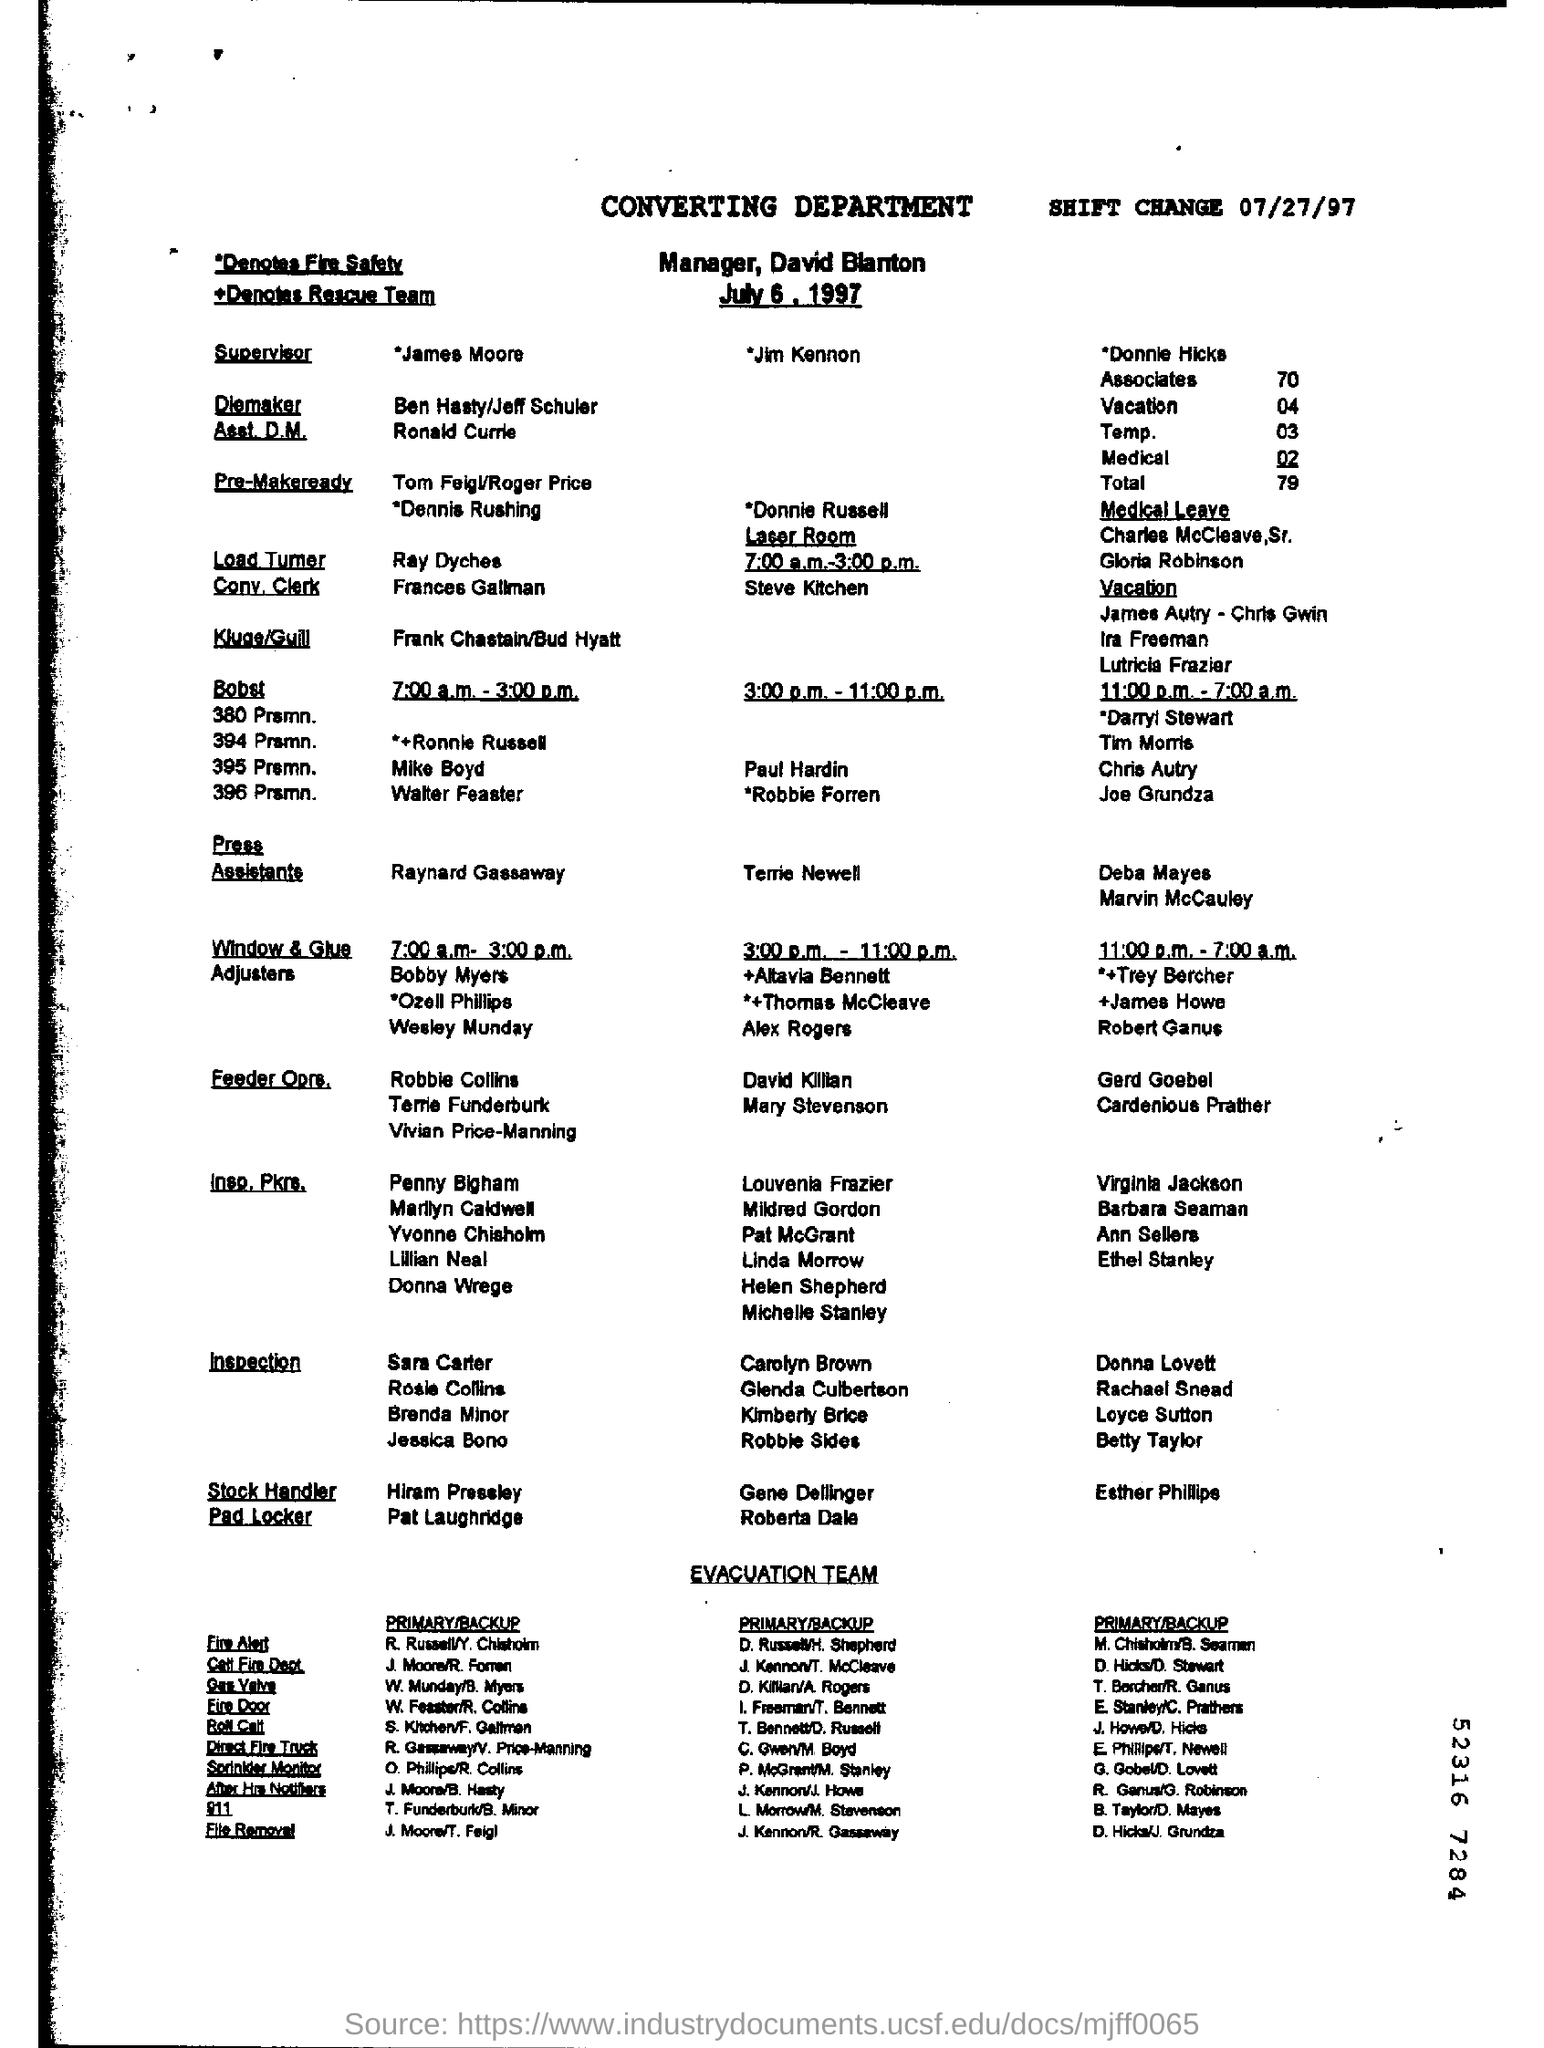Identify some key points in this picture. The "SHIFT CHANGE" date is July 27, 1997. The first shift timing for Window & Glue Adjusters is from 7:00 a.m. to 3:00 p.m. The person who is the manager is David Blanton. 